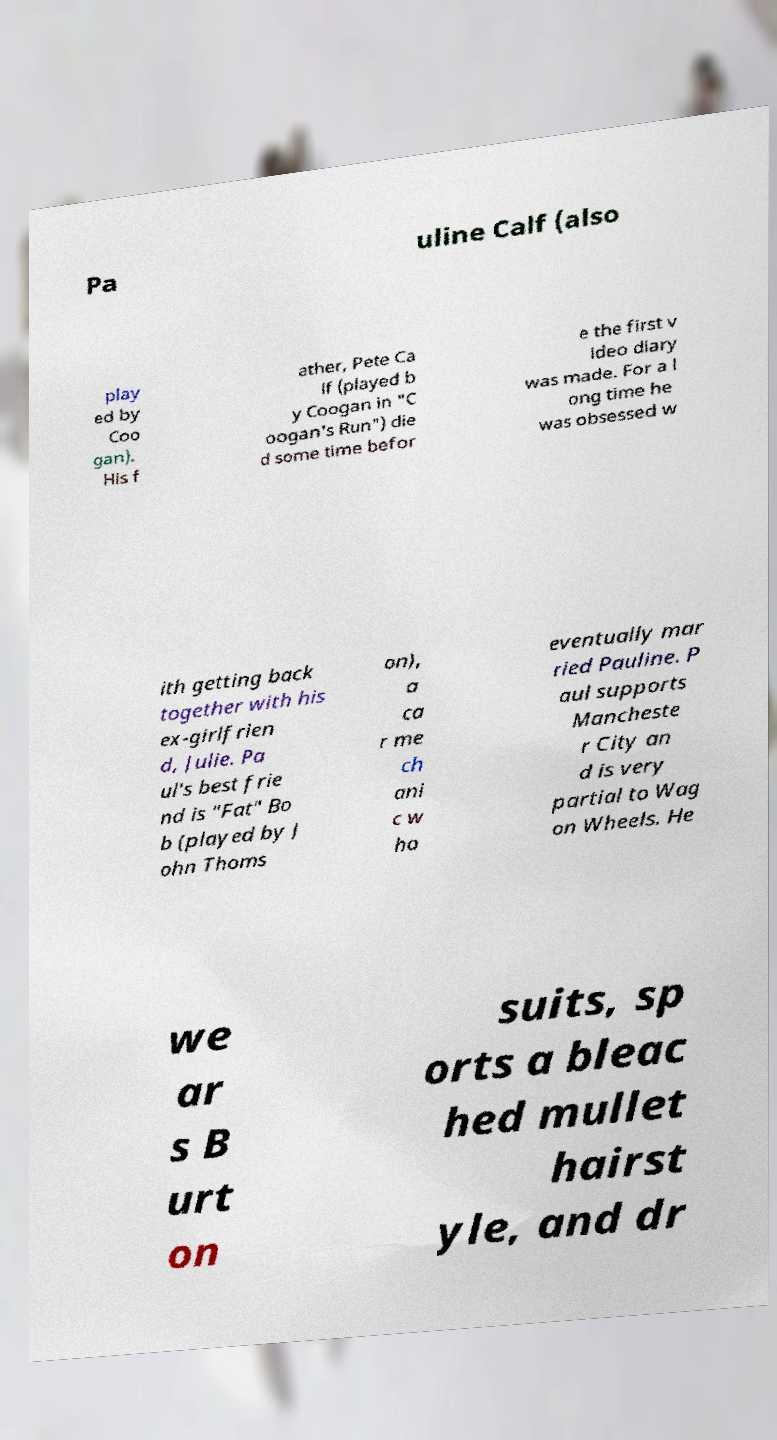There's text embedded in this image that I need extracted. Can you transcribe it verbatim? Pa uline Calf (also play ed by Coo gan). His f ather, Pete Ca lf (played b y Coogan in "C oogan's Run") die d some time befor e the first v ideo diary was made. For a l ong time he was obsessed w ith getting back together with his ex-girlfrien d, Julie. Pa ul's best frie nd is "Fat" Bo b (played by J ohn Thoms on), a ca r me ch ani c w ho eventually mar ried Pauline. P aul supports Mancheste r City an d is very partial to Wag on Wheels. He we ar s B urt on suits, sp orts a bleac hed mullet hairst yle, and dr 